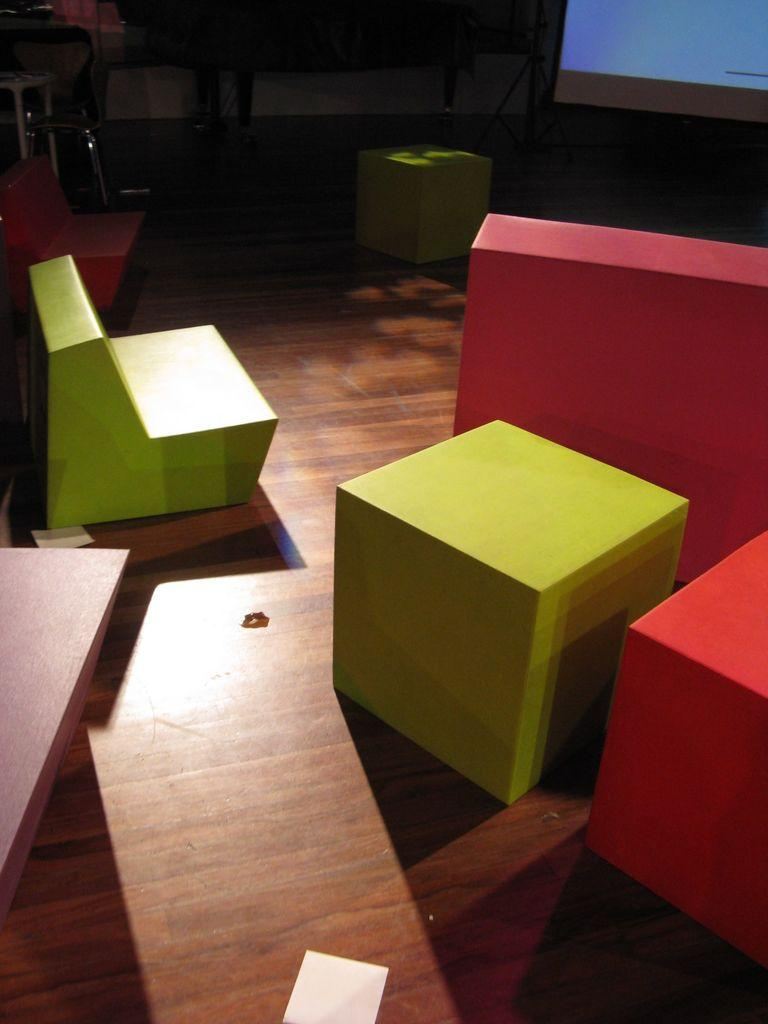What type of objects can be seen on the floor in the image? There are wooden blocks and a screen on the floor in the image. Can you describe the wooden blocks in the image? Unfortunately, the objects on the floor are not clear enough to describe in detail. What is the screen on the floor used for? The purpose of the screen on the floor is not clear from the image. How many bags can be seen in the image? There are no bags present in the image. What type of tramp is visible in the image? There is no tramp present in the image. 